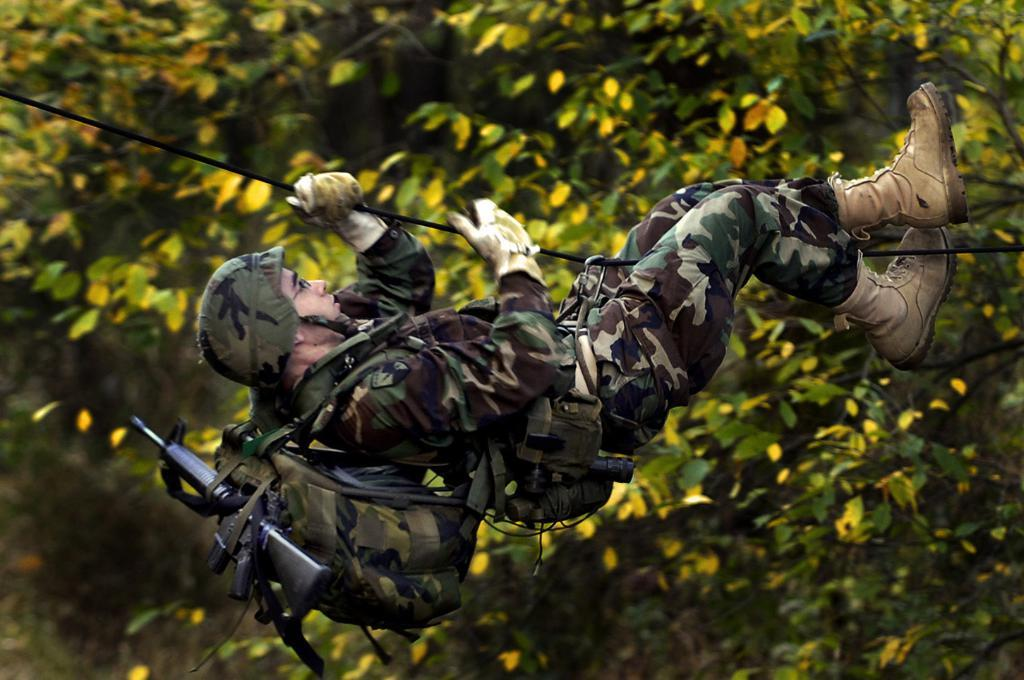What can be seen in the image? There is a person in the image. What is the person carrying? The person is carrying a bag. What is inside the bag? The bag contains a gun. What else is the person holding? The person is holding a rope. What protective gear is the person wearing? The person is wearing a helmet. What eyewear is the person wearing? The person is wearing spectacles. What can be seen in the background of the image? There are trees with leaves in the background of the image. How many balls can be seen in the image? There are no balls present in the image. What type of toad is sitting on the person's shoulder in the image? There is no toad present in the image. 